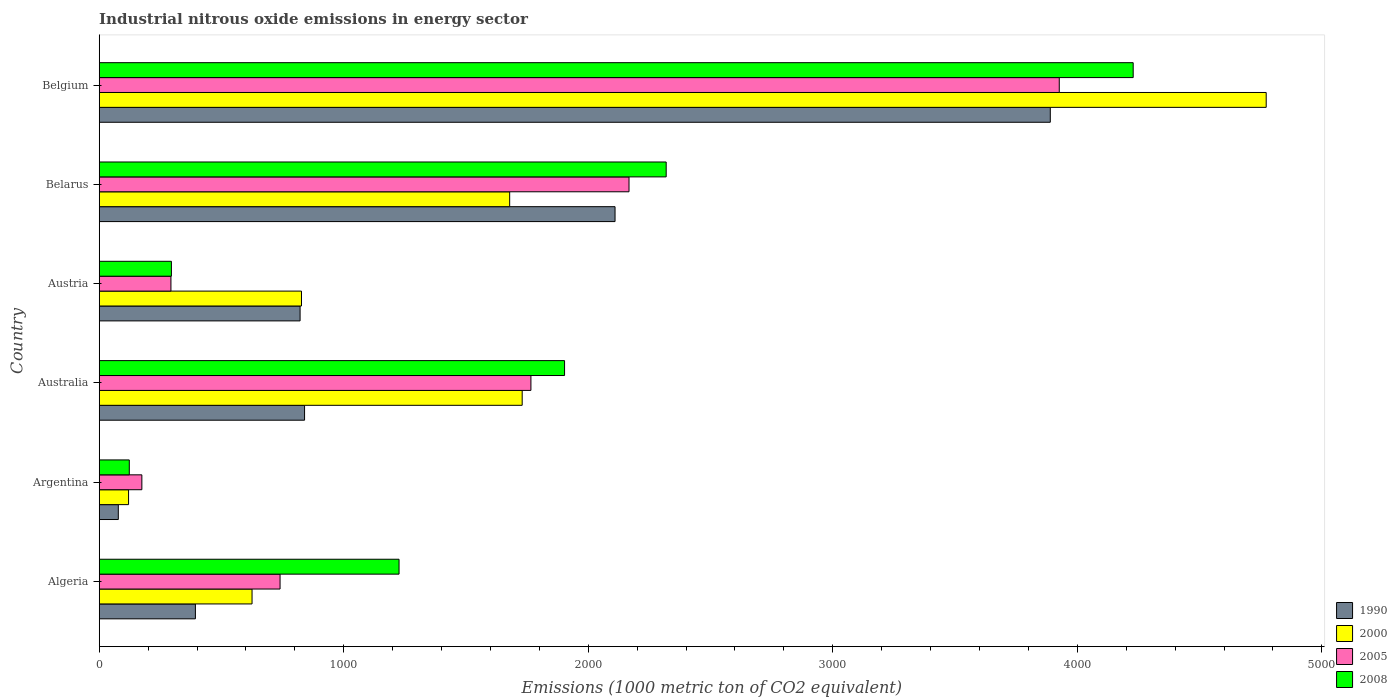How many groups of bars are there?
Make the answer very short. 6. Are the number of bars per tick equal to the number of legend labels?
Give a very brief answer. Yes. What is the label of the 3rd group of bars from the top?
Your response must be concise. Austria. What is the amount of industrial nitrous oxide emitted in 2000 in Algeria?
Provide a short and direct response. 625. Across all countries, what is the maximum amount of industrial nitrous oxide emitted in 1990?
Provide a succinct answer. 3889.6. Across all countries, what is the minimum amount of industrial nitrous oxide emitted in 2000?
Your response must be concise. 120. In which country was the amount of industrial nitrous oxide emitted in 2005 minimum?
Your answer should be very brief. Argentina. What is the total amount of industrial nitrous oxide emitted in 2005 in the graph?
Offer a terse response. 9065.8. What is the difference between the amount of industrial nitrous oxide emitted in 2000 in Algeria and that in Austria?
Provide a short and direct response. -202.2. What is the difference between the amount of industrial nitrous oxide emitted in 2005 in Australia and the amount of industrial nitrous oxide emitted in 2000 in Algeria?
Provide a short and direct response. 1140.5. What is the average amount of industrial nitrous oxide emitted in 2005 per country?
Provide a succinct answer. 1510.97. What is the difference between the amount of industrial nitrous oxide emitted in 2008 and amount of industrial nitrous oxide emitted in 2005 in Argentina?
Your answer should be very brief. -51.4. What is the ratio of the amount of industrial nitrous oxide emitted in 2000 in Austria to that in Belgium?
Keep it short and to the point. 0.17. Is the difference between the amount of industrial nitrous oxide emitted in 2008 in Algeria and Argentina greater than the difference between the amount of industrial nitrous oxide emitted in 2005 in Algeria and Argentina?
Offer a terse response. Yes. What is the difference between the highest and the second highest amount of industrial nitrous oxide emitted in 2000?
Your response must be concise. 3042.8. What is the difference between the highest and the lowest amount of industrial nitrous oxide emitted in 2008?
Ensure brevity in your answer.  4105.6. In how many countries, is the amount of industrial nitrous oxide emitted in 2000 greater than the average amount of industrial nitrous oxide emitted in 2000 taken over all countries?
Provide a short and direct response. 3. Is it the case that in every country, the sum of the amount of industrial nitrous oxide emitted in 2000 and amount of industrial nitrous oxide emitted in 1990 is greater than the sum of amount of industrial nitrous oxide emitted in 2005 and amount of industrial nitrous oxide emitted in 2008?
Give a very brief answer. No. What does the 3rd bar from the top in Belgium represents?
Offer a terse response. 2000. Is it the case that in every country, the sum of the amount of industrial nitrous oxide emitted in 2008 and amount of industrial nitrous oxide emitted in 2005 is greater than the amount of industrial nitrous oxide emitted in 2000?
Give a very brief answer. No. Are all the bars in the graph horizontal?
Offer a terse response. Yes. What is the difference between two consecutive major ticks on the X-axis?
Make the answer very short. 1000. Are the values on the major ticks of X-axis written in scientific E-notation?
Give a very brief answer. No. Does the graph contain any zero values?
Your answer should be very brief. No. Does the graph contain grids?
Make the answer very short. No. How are the legend labels stacked?
Give a very brief answer. Vertical. What is the title of the graph?
Offer a very short reply. Industrial nitrous oxide emissions in energy sector. What is the label or title of the X-axis?
Provide a succinct answer. Emissions (1000 metric ton of CO2 equivalent). What is the Emissions (1000 metric ton of CO2 equivalent) in 1990 in Algeria?
Offer a very short reply. 393.4. What is the Emissions (1000 metric ton of CO2 equivalent) of 2000 in Algeria?
Provide a succinct answer. 625. What is the Emissions (1000 metric ton of CO2 equivalent) of 2005 in Algeria?
Provide a succinct answer. 739.6. What is the Emissions (1000 metric ton of CO2 equivalent) of 2008 in Algeria?
Make the answer very short. 1226.2. What is the Emissions (1000 metric ton of CO2 equivalent) in 1990 in Argentina?
Offer a terse response. 78.1. What is the Emissions (1000 metric ton of CO2 equivalent) of 2000 in Argentina?
Keep it short and to the point. 120. What is the Emissions (1000 metric ton of CO2 equivalent) in 2005 in Argentina?
Provide a succinct answer. 174.4. What is the Emissions (1000 metric ton of CO2 equivalent) in 2008 in Argentina?
Your answer should be compact. 123. What is the Emissions (1000 metric ton of CO2 equivalent) of 1990 in Australia?
Your answer should be very brief. 839.8. What is the Emissions (1000 metric ton of CO2 equivalent) of 2000 in Australia?
Make the answer very short. 1729.8. What is the Emissions (1000 metric ton of CO2 equivalent) in 2005 in Australia?
Provide a short and direct response. 1765.5. What is the Emissions (1000 metric ton of CO2 equivalent) in 2008 in Australia?
Keep it short and to the point. 1903.1. What is the Emissions (1000 metric ton of CO2 equivalent) in 1990 in Austria?
Your answer should be compact. 821.5. What is the Emissions (1000 metric ton of CO2 equivalent) of 2000 in Austria?
Keep it short and to the point. 827.2. What is the Emissions (1000 metric ton of CO2 equivalent) in 2005 in Austria?
Your response must be concise. 293.3. What is the Emissions (1000 metric ton of CO2 equivalent) in 2008 in Austria?
Give a very brief answer. 295.2. What is the Emissions (1000 metric ton of CO2 equivalent) of 1990 in Belarus?
Make the answer very short. 2109.6. What is the Emissions (1000 metric ton of CO2 equivalent) in 2000 in Belarus?
Keep it short and to the point. 1678.6. What is the Emissions (1000 metric ton of CO2 equivalent) of 2005 in Belarus?
Provide a succinct answer. 2166.7. What is the Emissions (1000 metric ton of CO2 equivalent) in 2008 in Belarus?
Give a very brief answer. 2318.7. What is the Emissions (1000 metric ton of CO2 equivalent) in 1990 in Belgium?
Ensure brevity in your answer.  3889.6. What is the Emissions (1000 metric ton of CO2 equivalent) in 2000 in Belgium?
Your response must be concise. 4772.6. What is the Emissions (1000 metric ton of CO2 equivalent) of 2005 in Belgium?
Your response must be concise. 3926.3. What is the Emissions (1000 metric ton of CO2 equivalent) in 2008 in Belgium?
Give a very brief answer. 4228.6. Across all countries, what is the maximum Emissions (1000 metric ton of CO2 equivalent) in 1990?
Offer a terse response. 3889.6. Across all countries, what is the maximum Emissions (1000 metric ton of CO2 equivalent) of 2000?
Ensure brevity in your answer.  4772.6. Across all countries, what is the maximum Emissions (1000 metric ton of CO2 equivalent) of 2005?
Offer a terse response. 3926.3. Across all countries, what is the maximum Emissions (1000 metric ton of CO2 equivalent) in 2008?
Provide a succinct answer. 4228.6. Across all countries, what is the minimum Emissions (1000 metric ton of CO2 equivalent) in 1990?
Ensure brevity in your answer.  78.1. Across all countries, what is the minimum Emissions (1000 metric ton of CO2 equivalent) in 2000?
Provide a short and direct response. 120. Across all countries, what is the minimum Emissions (1000 metric ton of CO2 equivalent) of 2005?
Offer a very short reply. 174.4. Across all countries, what is the minimum Emissions (1000 metric ton of CO2 equivalent) of 2008?
Keep it short and to the point. 123. What is the total Emissions (1000 metric ton of CO2 equivalent) in 1990 in the graph?
Keep it short and to the point. 8132. What is the total Emissions (1000 metric ton of CO2 equivalent) of 2000 in the graph?
Give a very brief answer. 9753.2. What is the total Emissions (1000 metric ton of CO2 equivalent) of 2005 in the graph?
Your answer should be compact. 9065.8. What is the total Emissions (1000 metric ton of CO2 equivalent) in 2008 in the graph?
Offer a very short reply. 1.01e+04. What is the difference between the Emissions (1000 metric ton of CO2 equivalent) of 1990 in Algeria and that in Argentina?
Your answer should be very brief. 315.3. What is the difference between the Emissions (1000 metric ton of CO2 equivalent) of 2000 in Algeria and that in Argentina?
Give a very brief answer. 505. What is the difference between the Emissions (1000 metric ton of CO2 equivalent) in 2005 in Algeria and that in Argentina?
Give a very brief answer. 565.2. What is the difference between the Emissions (1000 metric ton of CO2 equivalent) of 2008 in Algeria and that in Argentina?
Your answer should be compact. 1103.2. What is the difference between the Emissions (1000 metric ton of CO2 equivalent) in 1990 in Algeria and that in Australia?
Keep it short and to the point. -446.4. What is the difference between the Emissions (1000 metric ton of CO2 equivalent) of 2000 in Algeria and that in Australia?
Provide a short and direct response. -1104.8. What is the difference between the Emissions (1000 metric ton of CO2 equivalent) in 2005 in Algeria and that in Australia?
Provide a short and direct response. -1025.9. What is the difference between the Emissions (1000 metric ton of CO2 equivalent) in 2008 in Algeria and that in Australia?
Provide a short and direct response. -676.9. What is the difference between the Emissions (1000 metric ton of CO2 equivalent) of 1990 in Algeria and that in Austria?
Make the answer very short. -428.1. What is the difference between the Emissions (1000 metric ton of CO2 equivalent) in 2000 in Algeria and that in Austria?
Offer a very short reply. -202.2. What is the difference between the Emissions (1000 metric ton of CO2 equivalent) in 2005 in Algeria and that in Austria?
Offer a terse response. 446.3. What is the difference between the Emissions (1000 metric ton of CO2 equivalent) in 2008 in Algeria and that in Austria?
Give a very brief answer. 931. What is the difference between the Emissions (1000 metric ton of CO2 equivalent) in 1990 in Algeria and that in Belarus?
Provide a succinct answer. -1716.2. What is the difference between the Emissions (1000 metric ton of CO2 equivalent) of 2000 in Algeria and that in Belarus?
Ensure brevity in your answer.  -1053.6. What is the difference between the Emissions (1000 metric ton of CO2 equivalent) in 2005 in Algeria and that in Belarus?
Your response must be concise. -1427.1. What is the difference between the Emissions (1000 metric ton of CO2 equivalent) in 2008 in Algeria and that in Belarus?
Provide a short and direct response. -1092.5. What is the difference between the Emissions (1000 metric ton of CO2 equivalent) of 1990 in Algeria and that in Belgium?
Your answer should be compact. -3496.2. What is the difference between the Emissions (1000 metric ton of CO2 equivalent) of 2000 in Algeria and that in Belgium?
Give a very brief answer. -4147.6. What is the difference between the Emissions (1000 metric ton of CO2 equivalent) in 2005 in Algeria and that in Belgium?
Provide a short and direct response. -3186.7. What is the difference between the Emissions (1000 metric ton of CO2 equivalent) in 2008 in Algeria and that in Belgium?
Your answer should be compact. -3002.4. What is the difference between the Emissions (1000 metric ton of CO2 equivalent) in 1990 in Argentina and that in Australia?
Ensure brevity in your answer.  -761.7. What is the difference between the Emissions (1000 metric ton of CO2 equivalent) of 2000 in Argentina and that in Australia?
Your answer should be very brief. -1609.8. What is the difference between the Emissions (1000 metric ton of CO2 equivalent) in 2005 in Argentina and that in Australia?
Provide a succinct answer. -1591.1. What is the difference between the Emissions (1000 metric ton of CO2 equivalent) in 2008 in Argentina and that in Australia?
Offer a terse response. -1780.1. What is the difference between the Emissions (1000 metric ton of CO2 equivalent) of 1990 in Argentina and that in Austria?
Give a very brief answer. -743.4. What is the difference between the Emissions (1000 metric ton of CO2 equivalent) in 2000 in Argentina and that in Austria?
Offer a very short reply. -707.2. What is the difference between the Emissions (1000 metric ton of CO2 equivalent) of 2005 in Argentina and that in Austria?
Provide a short and direct response. -118.9. What is the difference between the Emissions (1000 metric ton of CO2 equivalent) of 2008 in Argentina and that in Austria?
Your response must be concise. -172.2. What is the difference between the Emissions (1000 metric ton of CO2 equivalent) of 1990 in Argentina and that in Belarus?
Ensure brevity in your answer.  -2031.5. What is the difference between the Emissions (1000 metric ton of CO2 equivalent) of 2000 in Argentina and that in Belarus?
Your answer should be compact. -1558.6. What is the difference between the Emissions (1000 metric ton of CO2 equivalent) in 2005 in Argentina and that in Belarus?
Provide a succinct answer. -1992.3. What is the difference between the Emissions (1000 metric ton of CO2 equivalent) of 2008 in Argentina and that in Belarus?
Offer a very short reply. -2195.7. What is the difference between the Emissions (1000 metric ton of CO2 equivalent) in 1990 in Argentina and that in Belgium?
Give a very brief answer. -3811.5. What is the difference between the Emissions (1000 metric ton of CO2 equivalent) in 2000 in Argentina and that in Belgium?
Ensure brevity in your answer.  -4652.6. What is the difference between the Emissions (1000 metric ton of CO2 equivalent) in 2005 in Argentina and that in Belgium?
Ensure brevity in your answer.  -3751.9. What is the difference between the Emissions (1000 metric ton of CO2 equivalent) in 2008 in Argentina and that in Belgium?
Offer a very short reply. -4105.6. What is the difference between the Emissions (1000 metric ton of CO2 equivalent) in 2000 in Australia and that in Austria?
Provide a short and direct response. 902.6. What is the difference between the Emissions (1000 metric ton of CO2 equivalent) of 2005 in Australia and that in Austria?
Give a very brief answer. 1472.2. What is the difference between the Emissions (1000 metric ton of CO2 equivalent) in 2008 in Australia and that in Austria?
Your answer should be very brief. 1607.9. What is the difference between the Emissions (1000 metric ton of CO2 equivalent) of 1990 in Australia and that in Belarus?
Keep it short and to the point. -1269.8. What is the difference between the Emissions (1000 metric ton of CO2 equivalent) of 2000 in Australia and that in Belarus?
Your response must be concise. 51.2. What is the difference between the Emissions (1000 metric ton of CO2 equivalent) in 2005 in Australia and that in Belarus?
Offer a terse response. -401.2. What is the difference between the Emissions (1000 metric ton of CO2 equivalent) in 2008 in Australia and that in Belarus?
Offer a very short reply. -415.6. What is the difference between the Emissions (1000 metric ton of CO2 equivalent) of 1990 in Australia and that in Belgium?
Provide a succinct answer. -3049.8. What is the difference between the Emissions (1000 metric ton of CO2 equivalent) in 2000 in Australia and that in Belgium?
Offer a very short reply. -3042.8. What is the difference between the Emissions (1000 metric ton of CO2 equivalent) in 2005 in Australia and that in Belgium?
Your response must be concise. -2160.8. What is the difference between the Emissions (1000 metric ton of CO2 equivalent) in 2008 in Australia and that in Belgium?
Give a very brief answer. -2325.5. What is the difference between the Emissions (1000 metric ton of CO2 equivalent) in 1990 in Austria and that in Belarus?
Ensure brevity in your answer.  -1288.1. What is the difference between the Emissions (1000 metric ton of CO2 equivalent) in 2000 in Austria and that in Belarus?
Ensure brevity in your answer.  -851.4. What is the difference between the Emissions (1000 metric ton of CO2 equivalent) in 2005 in Austria and that in Belarus?
Your answer should be very brief. -1873.4. What is the difference between the Emissions (1000 metric ton of CO2 equivalent) of 2008 in Austria and that in Belarus?
Give a very brief answer. -2023.5. What is the difference between the Emissions (1000 metric ton of CO2 equivalent) in 1990 in Austria and that in Belgium?
Provide a short and direct response. -3068.1. What is the difference between the Emissions (1000 metric ton of CO2 equivalent) of 2000 in Austria and that in Belgium?
Keep it short and to the point. -3945.4. What is the difference between the Emissions (1000 metric ton of CO2 equivalent) in 2005 in Austria and that in Belgium?
Offer a terse response. -3633. What is the difference between the Emissions (1000 metric ton of CO2 equivalent) in 2008 in Austria and that in Belgium?
Offer a very short reply. -3933.4. What is the difference between the Emissions (1000 metric ton of CO2 equivalent) in 1990 in Belarus and that in Belgium?
Your answer should be very brief. -1780. What is the difference between the Emissions (1000 metric ton of CO2 equivalent) of 2000 in Belarus and that in Belgium?
Keep it short and to the point. -3094. What is the difference between the Emissions (1000 metric ton of CO2 equivalent) in 2005 in Belarus and that in Belgium?
Ensure brevity in your answer.  -1759.6. What is the difference between the Emissions (1000 metric ton of CO2 equivalent) of 2008 in Belarus and that in Belgium?
Make the answer very short. -1909.9. What is the difference between the Emissions (1000 metric ton of CO2 equivalent) in 1990 in Algeria and the Emissions (1000 metric ton of CO2 equivalent) in 2000 in Argentina?
Offer a very short reply. 273.4. What is the difference between the Emissions (1000 metric ton of CO2 equivalent) in 1990 in Algeria and the Emissions (1000 metric ton of CO2 equivalent) in 2005 in Argentina?
Offer a terse response. 219. What is the difference between the Emissions (1000 metric ton of CO2 equivalent) of 1990 in Algeria and the Emissions (1000 metric ton of CO2 equivalent) of 2008 in Argentina?
Provide a succinct answer. 270.4. What is the difference between the Emissions (1000 metric ton of CO2 equivalent) of 2000 in Algeria and the Emissions (1000 metric ton of CO2 equivalent) of 2005 in Argentina?
Provide a short and direct response. 450.6. What is the difference between the Emissions (1000 metric ton of CO2 equivalent) in 2000 in Algeria and the Emissions (1000 metric ton of CO2 equivalent) in 2008 in Argentina?
Keep it short and to the point. 502. What is the difference between the Emissions (1000 metric ton of CO2 equivalent) in 2005 in Algeria and the Emissions (1000 metric ton of CO2 equivalent) in 2008 in Argentina?
Keep it short and to the point. 616.6. What is the difference between the Emissions (1000 metric ton of CO2 equivalent) of 1990 in Algeria and the Emissions (1000 metric ton of CO2 equivalent) of 2000 in Australia?
Keep it short and to the point. -1336.4. What is the difference between the Emissions (1000 metric ton of CO2 equivalent) in 1990 in Algeria and the Emissions (1000 metric ton of CO2 equivalent) in 2005 in Australia?
Your answer should be very brief. -1372.1. What is the difference between the Emissions (1000 metric ton of CO2 equivalent) of 1990 in Algeria and the Emissions (1000 metric ton of CO2 equivalent) of 2008 in Australia?
Your answer should be compact. -1509.7. What is the difference between the Emissions (1000 metric ton of CO2 equivalent) in 2000 in Algeria and the Emissions (1000 metric ton of CO2 equivalent) in 2005 in Australia?
Provide a short and direct response. -1140.5. What is the difference between the Emissions (1000 metric ton of CO2 equivalent) in 2000 in Algeria and the Emissions (1000 metric ton of CO2 equivalent) in 2008 in Australia?
Your response must be concise. -1278.1. What is the difference between the Emissions (1000 metric ton of CO2 equivalent) of 2005 in Algeria and the Emissions (1000 metric ton of CO2 equivalent) of 2008 in Australia?
Ensure brevity in your answer.  -1163.5. What is the difference between the Emissions (1000 metric ton of CO2 equivalent) in 1990 in Algeria and the Emissions (1000 metric ton of CO2 equivalent) in 2000 in Austria?
Provide a short and direct response. -433.8. What is the difference between the Emissions (1000 metric ton of CO2 equivalent) in 1990 in Algeria and the Emissions (1000 metric ton of CO2 equivalent) in 2005 in Austria?
Provide a succinct answer. 100.1. What is the difference between the Emissions (1000 metric ton of CO2 equivalent) in 1990 in Algeria and the Emissions (1000 metric ton of CO2 equivalent) in 2008 in Austria?
Your answer should be compact. 98.2. What is the difference between the Emissions (1000 metric ton of CO2 equivalent) in 2000 in Algeria and the Emissions (1000 metric ton of CO2 equivalent) in 2005 in Austria?
Make the answer very short. 331.7. What is the difference between the Emissions (1000 metric ton of CO2 equivalent) in 2000 in Algeria and the Emissions (1000 metric ton of CO2 equivalent) in 2008 in Austria?
Offer a very short reply. 329.8. What is the difference between the Emissions (1000 metric ton of CO2 equivalent) in 2005 in Algeria and the Emissions (1000 metric ton of CO2 equivalent) in 2008 in Austria?
Your answer should be very brief. 444.4. What is the difference between the Emissions (1000 metric ton of CO2 equivalent) of 1990 in Algeria and the Emissions (1000 metric ton of CO2 equivalent) of 2000 in Belarus?
Your answer should be compact. -1285.2. What is the difference between the Emissions (1000 metric ton of CO2 equivalent) of 1990 in Algeria and the Emissions (1000 metric ton of CO2 equivalent) of 2005 in Belarus?
Your answer should be very brief. -1773.3. What is the difference between the Emissions (1000 metric ton of CO2 equivalent) in 1990 in Algeria and the Emissions (1000 metric ton of CO2 equivalent) in 2008 in Belarus?
Ensure brevity in your answer.  -1925.3. What is the difference between the Emissions (1000 metric ton of CO2 equivalent) of 2000 in Algeria and the Emissions (1000 metric ton of CO2 equivalent) of 2005 in Belarus?
Offer a terse response. -1541.7. What is the difference between the Emissions (1000 metric ton of CO2 equivalent) in 2000 in Algeria and the Emissions (1000 metric ton of CO2 equivalent) in 2008 in Belarus?
Ensure brevity in your answer.  -1693.7. What is the difference between the Emissions (1000 metric ton of CO2 equivalent) in 2005 in Algeria and the Emissions (1000 metric ton of CO2 equivalent) in 2008 in Belarus?
Your response must be concise. -1579.1. What is the difference between the Emissions (1000 metric ton of CO2 equivalent) in 1990 in Algeria and the Emissions (1000 metric ton of CO2 equivalent) in 2000 in Belgium?
Your answer should be very brief. -4379.2. What is the difference between the Emissions (1000 metric ton of CO2 equivalent) in 1990 in Algeria and the Emissions (1000 metric ton of CO2 equivalent) in 2005 in Belgium?
Offer a very short reply. -3532.9. What is the difference between the Emissions (1000 metric ton of CO2 equivalent) in 1990 in Algeria and the Emissions (1000 metric ton of CO2 equivalent) in 2008 in Belgium?
Your answer should be compact. -3835.2. What is the difference between the Emissions (1000 metric ton of CO2 equivalent) of 2000 in Algeria and the Emissions (1000 metric ton of CO2 equivalent) of 2005 in Belgium?
Provide a short and direct response. -3301.3. What is the difference between the Emissions (1000 metric ton of CO2 equivalent) of 2000 in Algeria and the Emissions (1000 metric ton of CO2 equivalent) of 2008 in Belgium?
Provide a succinct answer. -3603.6. What is the difference between the Emissions (1000 metric ton of CO2 equivalent) in 2005 in Algeria and the Emissions (1000 metric ton of CO2 equivalent) in 2008 in Belgium?
Ensure brevity in your answer.  -3489. What is the difference between the Emissions (1000 metric ton of CO2 equivalent) in 1990 in Argentina and the Emissions (1000 metric ton of CO2 equivalent) in 2000 in Australia?
Your answer should be very brief. -1651.7. What is the difference between the Emissions (1000 metric ton of CO2 equivalent) in 1990 in Argentina and the Emissions (1000 metric ton of CO2 equivalent) in 2005 in Australia?
Your answer should be very brief. -1687.4. What is the difference between the Emissions (1000 metric ton of CO2 equivalent) in 1990 in Argentina and the Emissions (1000 metric ton of CO2 equivalent) in 2008 in Australia?
Your answer should be compact. -1825. What is the difference between the Emissions (1000 metric ton of CO2 equivalent) of 2000 in Argentina and the Emissions (1000 metric ton of CO2 equivalent) of 2005 in Australia?
Keep it short and to the point. -1645.5. What is the difference between the Emissions (1000 metric ton of CO2 equivalent) in 2000 in Argentina and the Emissions (1000 metric ton of CO2 equivalent) in 2008 in Australia?
Provide a short and direct response. -1783.1. What is the difference between the Emissions (1000 metric ton of CO2 equivalent) in 2005 in Argentina and the Emissions (1000 metric ton of CO2 equivalent) in 2008 in Australia?
Provide a short and direct response. -1728.7. What is the difference between the Emissions (1000 metric ton of CO2 equivalent) of 1990 in Argentina and the Emissions (1000 metric ton of CO2 equivalent) of 2000 in Austria?
Offer a very short reply. -749.1. What is the difference between the Emissions (1000 metric ton of CO2 equivalent) in 1990 in Argentina and the Emissions (1000 metric ton of CO2 equivalent) in 2005 in Austria?
Your response must be concise. -215.2. What is the difference between the Emissions (1000 metric ton of CO2 equivalent) of 1990 in Argentina and the Emissions (1000 metric ton of CO2 equivalent) of 2008 in Austria?
Provide a succinct answer. -217.1. What is the difference between the Emissions (1000 metric ton of CO2 equivalent) of 2000 in Argentina and the Emissions (1000 metric ton of CO2 equivalent) of 2005 in Austria?
Provide a short and direct response. -173.3. What is the difference between the Emissions (1000 metric ton of CO2 equivalent) in 2000 in Argentina and the Emissions (1000 metric ton of CO2 equivalent) in 2008 in Austria?
Provide a succinct answer. -175.2. What is the difference between the Emissions (1000 metric ton of CO2 equivalent) in 2005 in Argentina and the Emissions (1000 metric ton of CO2 equivalent) in 2008 in Austria?
Provide a short and direct response. -120.8. What is the difference between the Emissions (1000 metric ton of CO2 equivalent) in 1990 in Argentina and the Emissions (1000 metric ton of CO2 equivalent) in 2000 in Belarus?
Your answer should be very brief. -1600.5. What is the difference between the Emissions (1000 metric ton of CO2 equivalent) of 1990 in Argentina and the Emissions (1000 metric ton of CO2 equivalent) of 2005 in Belarus?
Provide a succinct answer. -2088.6. What is the difference between the Emissions (1000 metric ton of CO2 equivalent) in 1990 in Argentina and the Emissions (1000 metric ton of CO2 equivalent) in 2008 in Belarus?
Your answer should be compact. -2240.6. What is the difference between the Emissions (1000 metric ton of CO2 equivalent) in 2000 in Argentina and the Emissions (1000 metric ton of CO2 equivalent) in 2005 in Belarus?
Offer a very short reply. -2046.7. What is the difference between the Emissions (1000 metric ton of CO2 equivalent) of 2000 in Argentina and the Emissions (1000 metric ton of CO2 equivalent) of 2008 in Belarus?
Ensure brevity in your answer.  -2198.7. What is the difference between the Emissions (1000 metric ton of CO2 equivalent) of 2005 in Argentina and the Emissions (1000 metric ton of CO2 equivalent) of 2008 in Belarus?
Give a very brief answer. -2144.3. What is the difference between the Emissions (1000 metric ton of CO2 equivalent) of 1990 in Argentina and the Emissions (1000 metric ton of CO2 equivalent) of 2000 in Belgium?
Provide a succinct answer. -4694.5. What is the difference between the Emissions (1000 metric ton of CO2 equivalent) of 1990 in Argentina and the Emissions (1000 metric ton of CO2 equivalent) of 2005 in Belgium?
Provide a succinct answer. -3848.2. What is the difference between the Emissions (1000 metric ton of CO2 equivalent) in 1990 in Argentina and the Emissions (1000 metric ton of CO2 equivalent) in 2008 in Belgium?
Provide a succinct answer. -4150.5. What is the difference between the Emissions (1000 metric ton of CO2 equivalent) in 2000 in Argentina and the Emissions (1000 metric ton of CO2 equivalent) in 2005 in Belgium?
Your answer should be very brief. -3806.3. What is the difference between the Emissions (1000 metric ton of CO2 equivalent) of 2000 in Argentina and the Emissions (1000 metric ton of CO2 equivalent) of 2008 in Belgium?
Provide a succinct answer. -4108.6. What is the difference between the Emissions (1000 metric ton of CO2 equivalent) in 2005 in Argentina and the Emissions (1000 metric ton of CO2 equivalent) in 2008 in Belgium?
Make the answer very short. -4054.2. What is the difference between the Emissions (1000 metric ton of CO2 equivalent) in 1990 in Australia and the Emissions (1000 metric ton of CO2 equivalent) in 2005 in Austria?
Offer a terse response. 546.5. What is the difference between the Emissions (1000 metric ton of CO2 equivalent) of 1990 in Australia and the Emissions (1000 metric ton of CO2 equivalent) of 2008 in Austria?
Make the answer very short. 544.6. What is the difference between the Emissions (1000 metric ton of CO2 equivalent) in 2000 in Australia and the Emissions (1000 metric ton of CO2 equivalent) in 2005 in Austria?
Your answer should be very brief. 1436.5. What is the difference between the Emissions (1000 metric ton of CO2 equivalent) in 2000 in Australia and the Emissions (1000 metric ton of CO2 equivalent) in 2008 in Austria?
Offer a terse response. 1434.6. What is the difference between the Emissions (1000 metric ton of CO2 equivalent) in 2005 in Australia and the Emissions (1000 metric ton of CO2 equivalent) in 2008 in Austria?
Provide a succinct answer. 1470.3. What is the difference between the Emissions (1000 metric ton of CO2 equivalent) of 1990 in Australia and the Emissions (1000 metric ton of CO2 equivalent) of 2000 in Belarus?
Offer a very short reply. -838.8. What is the difference between the Emissions (1000 metric ton of CO2 equivalent) in 1990 in Australia and the Emissions (1000 metric ton of CO2 equivalent) in 2005 in Belarus?
Keep it short and to the point. -1326.9. What is the difference between the Emissions (1000 metric ton of CO2 equivalent) of 1990 in Australia and the Emissions (1000 metric ton of CO2 equivalent) of 2008 in Belarus?
Offer a terse response. -1478.9. What is the difference between the Emissions (1000 metric ton of CO2 equivalent) of 2000 in Australia and the Emissions (1000 metric ton of CO2 equivalent) of 2005 in Belarus?
Make the answer very short. -436.9. What is the difference between the Emissions (1000 metric ton of CO2 equivalent) in 2000 in Australia and the Emissions (1000 metric ton of CO2 equivalent) in 2008 in Belarus?
Make the answer very short. -588.9. What is the difference between the Emissions (1000 metric ton of CO2 equivalent) of 2005 in Australia and the Emissions (1000 metric ton of CO2 equivalent) of 2008 in Belarus?
Your response must be concise. -553.2. What is the difference between the Emissions (1000 metric ton of CO2 equivalent) in 1990 in Australia and the Emissions (1000 metric ton of CO2 equivalent) in 2000 in Belgium?
Provide a short and direct response. -3932.8. What is the difference between the Emissions (1000 metric ton of CO2 equivalent) in 1990 in Australia and the Emissions (1000 metric ton of CO2 equivalent) in 2005 in Belgium?
Give a very brief answer. -3086.5. What is the difference between the Emissions (1000 metric ton of CO2 equivalent) in 1990 in Australia and the Emissions (1000 metric ton of CO2 equivalent) in 2008 in Belgium?
Your answer should be compact. -3388.8. What is the difference between the Emissions (1000 metric ton of CO2 equivalent) in 2000 in Australia and the Emissions (1000 metric ton of CO2 equivalent) in 2005 in Belgium?
Offer a very short reply. -2196.5. What is the difference between the Emissions (1000 metric ton of CO2 equivalent) of 2000 in Australia and the Emissions (1000 metric ton of CO2 equivalent) of 2008 in Belgium?
Provide a short and direct response. -2498.8. What is the difference between the Emissions (1000 metric ton of CO2 equivalent) in 2005 in Australia and the Emissions (1000 metric ton of CO2 equivalent) in 2008 in Belgium?
Your answer should be very brief. -2463.1. What is the difference between the Emissions (1000 metric ton of CO2 equivalent) of 1990 in Austria and the Emissions (1000 metric ton of CO2 equivalent) of 2000 in Belarus?
Provide a short and direct response. -857.1. What is the difference between the Emissions (1000 metric ton of CO2 equivalent) in 1990 in Austria and the Emissions (1000 metric ton of CO2 equivalent) in 2005 in Belarus?
Your response must be concise. -1345.2. What is the difference between the Emissions (1000 metric ton of CO2 equivalent) in 1990 in Austria and the Emissions (1000 metric ton of CO2 equivalent) in 2008 in Belarus?
Give a very brief answer. -1497.2. What is the difference between the Emissions (1000 metric ton of CO2 equivalent) in 2000 in Austria and the Emissions (1000 metric ton of CO2 equivalent) in 2005 in Belarus?
Your response must be concise. -1339.5. What is the difference between the Emissions (1000 metric ton of CO2 equivalent) in 2000 in Austria and the Emissions (1000 metric ton of CO2 equivalent) in 2008 in Belarus?
Give a very brief answer. -1491.5. What is the difference between the Emissions (1000 metric ton of CO2 equivalent) of 2005 in Austria and the Emissions (1000 metric ton of CO2 equivalent) of 2008 in Belarus?
Give a very brief answer. -2025.4. What is the difference between the Emissions (1000 metric ton of CO2 equivalent) in 1990 in Austria and the Emissions (1000 metric ton of CO2 equivalent) in 2000 in Belgium?
Give a very brief answer. -3951.1. What is the difference between the Emissions (1000 metric ton of CO2 equivalent) in 1990 in Austria and the Emissions (1000 metric ton of CO2 equivalent) in 2005 in Belgium?
Provide a succinct answer. -3104.8. What is the difference between the Emissions (1000 metric ton of CO2 equivalent) of 1990 in Austria and the Emissions (1000 metric ton of CO2 equivalent) of 2008 in Belgium?
Provide a succinct answer. -3407.1. What is the difference between the Emissions (1000 metric ton of CO2 equivalent) of 2000 in Austria and the Emissions (1000 metric ton of CO2 equivalent) of 2005 in Belgium?
Ensure brevity in your answer.  -3099.1. What is the difference between the Emissions (1000 metric ton of CO2 equivalent) of 2000 in Austria and the Emissions (1000 metric ton of CO2 equivalent) of 2008 in Belgium?
Offer a terse response. -3401.4. What is the difference between the Emissions (1000 metric ton of CO2 equivalent) in 2005 in Austria and the Emissions (1000 metric ton of CO2 equivalent) in 2008 in Belgium?
Make the answer very short. -3935.3. What is the difference between the Emissions (1000 metric ton of CO2 equivalent) in 1990 in Belarus and the Emissions (1000 metric ton of CO2 equivalent) in 2000 in Belgium?
Provide a short and direct response. -2663. What is the difference between the Emissions (1000 metric ton of CO2 equivalent) of 1990 in Belarus and the Emissions (1000 metric ton of CO2 equivalent) of 2005 in Belgium?
Keep it short and to the point. -1816.7. What is the difference between the Emissions (1000 metric ton of CO2 equivalent) in 1990 in Belarus and the Emissions (1000 metric ton of CO2 equivalent) in 2008 in Belgium?
Offer a terse response. -2119. What is the difference between the Emissions (1000 metric ton of CO2 equivalent) in 2000 in Belarus and the Emissions (1000 metric ton of CO2 equivalent) in 2005 in Belgium?
Your response must be concise. -2247.7. What is the difference between the Emissions (1000 metric ton of CO2 equivalent) in 2000 in Belarus and the Emissions (1000 metric ton of CO2 equivalent) in 2008 in Belgium?
Ensure brevity in your answer.  -2550. What is the difference between the Emissions (1000 metric ton of CO2 equivalent) of 2005 in Belarus and the Emissions (1000 metric ton of CO2 equivalent) of 2008 in Belgium?
Give a very brief answer. -2061.9. What is the average Emissions (1000 metric ton of CO2 equivalent) of 1990 per country?
Offer a very short reply. 1355.33. What is the average Emissions (1000 metric ton of CO2 equivalent) in 2000 per country?
Provide a short and direct response. 1625.53. What is the average Emissions (1000 metric ton of CO2 equivalent) in 2005 per country?
Offer a terse response. 1510.97. What is the average Emissions (1000 metric ton of CO2 equivalent) in 2008 per country?
Provide a succinct answer. 1682.47. What is the difference between the Emissions (1000 metric ton of CO2 equivalent) of 1990 and Emissions (1000 metric ton of CO2 equivalent) of 2000 in Algeria?
Give a very brief answer. -231.6. What is the difference between the Emissions (1000 metric ton of CO2 equivalent) in 1990 and Emissions (1000 metric ton of CO2 equivalent) in 2005 in Algeria?
Offer a terse response. -346.2. What is the difference between the Emissions (1000 metric ton of CO2 equivalent) in 1990 and Emissions (1000 metric ton of CO2 equivalent) in 2008 in Algeria?
Make the answer very short. -832.8. What is the difference between the Emissions (1000 metric ton of CO2 equivalent) of 2000 and Emissions (1000 metric ton of CO2 equivalent) of 2005 in Algeria?
Ensure brevity in your answer.  -114.6. What is the difference between the Emissions (1000 metric ton of CO2 equivalent) of 2000 and Emissions (1000 metric ton of CO2 equivalent) of 2008 in Algeria?
Give a very brief answer. -601.2. What is the difference between the Emissions (1000 metric ton of CO2 equivalent) in 2005 and Emissions (1000 metric ton of CO2 equivalent) in 2008 in Algeria?
Provide a short and direct response. -486.6. What is the difference between the Emissions (1000 metric ton of CO2 equivalent) of 1990 and Emissions (1000 metric ton of CO2 equivalent) of 2000 in Argentina?
Give a very brief answer. -41.9. What is the difference between the Emissions (1000 metric ton of CO2 equivalent) of 1990 and Emissions (1000 metric ton of CO2 equivalent) of 2005 in Argentina?
Provide a succinct answer. -96.3. What is the difference between the Emissions (1000 metric ton of CO2 equivalent) in 1990 and Emissions (1000 metric ton of CO2 equivalent) in 2008 in Argentina?
Your answer should be very brief. -44.9. What is the difference between the Emissions (1000 metric ton of CO2 equivalent) of 2000 and Emissions (1000 metric ton of CO2 equivalent) of 2005 in Argentina?
Offer a terse response. -54.4. What is the difference between the Emissions (1000 metric ton of CO2 equivalent) of 2005 and Emissions (1000 metric ton of CO2 equivalent) of 2008 in Argentina?
Your response must be concise. 51.4. What is the difference between the Emissions (1000 metric ton of CO2 equivalent) in 1990 and Emissions (1000 metric ton of CO2 equivalent) in 2000 in Australia?
Provide a succinct answer. -890. What is the difference between the Emissions (1000 metric ton of CO2 equivalent) in 1990 and Emissions (1000 metric ton of CO2 equivalent) in 2005 in Australia?
Offer a very short reply. -925.7. What is the difference between the Emissions (1000 metric ton of CO2 equivalent) in 1990 and Emissions (1000 metric ton of CO2 equivalent) in 2008 in Australia?
Your answer should be compact. -1063.3. What is the difference between the Emissions (1000 metric ton of CO2 equivalent) of 2000 and Emissions (1000 metric ton of CO2 equivalent) of 2005 in Australia?
Offer a terse response. -35.7. What is the difference between the Emissions (1000 metric ton of CO2 equivalent) of 2000 and Emissions (1000 metric ton of CO2 equivalent) of 2008 in Australia?
Ensure brevity in your answer.  -173.3. What is the difference between the Emissions (1000 metric ton of CO2 equivalent) of 2005 and Emissions (1000 metric ton of CO2 equivalent) of 2008 in Australia?
Your answer should be very brief. -137.6. What is the difference between the Emissions (1000 metric ton of CO2 equivalent) in 1990 and Emissions (1000 metric ton of CO2 equivalent) in 2005 in Austria?
Provide a succinct answer. 528.2. What is the difference between the Emissions (1000 metric ton of CO2 equivalent) in 1990 and Emissions (1000 metric ton of CO2 equivalent) in 2008 in Austria?
Make the answer very short. 526.3. What is the difference between the Emissions (1000 metric ton of CO2 equivalent) of 2000 and Emissions (1000 metric ton of CO2 equivalent) of 2005 in Austria?
Make the answer very short. 533.9. What is the difference between the Emissions (1000 metric ton of CO2 equivalent) of 2000 and Emissions (1000 metric ton of CO2 equivalent) of 2008 in Austria?
Make the answer very short. 532. What is the difference between the Emissions (1000 metric ton of CO2 equivalent) of 2005 and Emissions (1000 metric ton of CO2 equivalent) of 2008 in Austria?
Provide a succinct answer. -1.9. What is the difference between the Emissions (1000 metric ton of CO2 equivalent) in 1990 and Emissions (1000 metric ton of CO2 equivalent) in 2000 in Belarus?
Provide a succinct answer. 431. What is the difference between the Emissions (1000 metric ton of CO2 equivalent) of 1990 and Emissions (1000 metric ton of CO2 equivalent) of 2005 in Belarus?
Give a very brief answer. -57.1. What is the difference between the Emissions (1000 metric ton of CO2 equivalent) in 1990 and Emissions (1000 metric ton of CO2 equivalent) in 2008 in Belarus?
Make the answer very short. -209.1. What is the difference between the Emissions (1000 metric ton of CO2 equivalent) of 2000 and Emissions (1000 metric ton of CO2 equivalent) of 2005 in Belarus?
Make the answer very short. -488.1. What is the difference between the Emissions (1000 metric ton of CO2 equivalent) of 2000 and Emissions (1000 metric ton of CO2 equivalent) of 2008 in Belarus?
Provide a short and direct response. -640.1. What is the difference between the Emissions (1000 metric ton of CO2 equivalent) in 2005 and Emissions (1000 metric ton of CO2 equivalent) in 2008 in Belarus?
Offer a very short reply. -152. What is the difference between the Emissions (1000 metric ton of CO2 equivalent) in 1990 and Emissions (1000 metric ton of CO2 equivalent) in 2000 in Belgium?
Keep it short and to the point. -883. What is the difference between the Emissions (1000 metric ton of CO2 equivalent) of 1990 and Emissions (1000 metric ton of CO2 equivalent) of 2005 in Belgium?
Your answer should be very brief. -36.7. What is the difference between the Emissions (1000 metric ton of CO2 equivalent) of 1990 and Emissions (1000 metric ton of CO2 equivalent) of 2008 in Belgium?
Your response must be concise. -339. What is the difference between the Emissions (1000 metric ton of CO2 equivalent) of 2000 and Emissions (1000 metric ton of CO2 equivalent) of 2005 in Belgium?
Ensure brevity in your answer.  846.3. What is the difference between the Emissions (1000 metric ton of CO2 equivalent) of 2000 and Emissions (1000 metric ton of CO2 equivalent) of 2008 in Belgium?
Offer a terse response. 544. What is the difference between the Emissions (1000 metric ton of CO2 equivalent) in 2005 and Emissions (1000 metric ton of CO2 equivalent) in 2008 in Belgium?
Your answer should be compact. -302.3. What is the ratio of the Emissions (1000 metric ton of CO2 equivalent) of 1990 in Algeria to that in Argentina?
Ensure brevity in your answer.  5.04. What is the ratio of the Emissions (1000 metric ton of CO2 equivalent) of 2000 in Algeria to that in Argentina?
Make the answer very short. 5.21. What is the ratio of the Emissions (1000 metric ton of CO2 equivalent) in 2005 in Algeria to that in Argentina?
Give a very brief answer. 4.24. What is the ratio of the Emissions (1000 metric ton of CO2 equivalent) in 2008 in Algeria to that in Argentina?
Provide a short and direct response. 9.97. What is the ratio of the Emissions (1000 metric ton of CO2 equivalent) of 1990 in Algeria to that in Australia?
Give a very brief answer. 0.47. What is the ratio of the Emissions (1000 metric ton of CO2 equivalent) in 2000 in Algeria to that in Australia?
Offer a terse response. 0.36. What is the ratio of the Emissions (1000 metric ton of CO2 equivalent) in 2005 in Algeria to that in Australia?
Your answer should be very brief. 0.42. What is the ratio of the Emissions (1000 metric ton of CO2 equivalent) of 2008 in Algeria to that in Australia?
Provide a succinct answer. 0.64. What is the ratio of the Emissions (1000 metric ton of CO2 equivalent) in 1990 in Algeria to that in Austria?
Offer a terse response. 0.48. What is the ratio of the Emissions (1000 metric ton of CO2 equivalent) of 2000 in Algeria to that in Austria?
Your answer should be very brief. 0.76. What is the ratio of the Emissions (1000 metric ton of CO2 equivalent) in 2005 in Algeria to that in Austria?
Your answer should be compact. 2.52. What is the ratio of the Emissions (1000 metric ton of CO2 equivalent) of 2008 in Algeria to that in Austria?
Offer a very short reply. 4.15. What is the ratio of the Emissions (1000 metric ton of CO2 equivalent) of 1990 in Algeria to that in Belarus?
Keep it short and to the point. 0.19. What is the ratio of the Emissions (1000 metric ton of CO2 equivalent) in 2000 in Algeria to that in Belarus?
Offer a terse response. 0.37. What is the ratio of the Emissions (1000 metric ton of CO2 equivalent) in 2005 in Algeria to that in Belarus?
Offer a terse response. 0.34. What is the ratio of the Emissions (1000 metric ton of CO2 equivalent) of 2008 in Algeria to that in Belarus?
Offer a terse response. 0.53. What is the ratio of the Emissions (1000 metric ton of CO2 equivalent) of 1990 in Algeria to that in Belgium?
Provide a succinct answer. 0.1. What is the ratio of the Emissions (1000 metric ton of CO2 equivalent) of 2000 in Algeria to that in Belgium?
Offer a terse response. 0.13. What is the ratio of the Emissions (1000 metric ton of CO2 equivalent) of 2005 in Algeria to that in Belgium?
Offer a very short reply. 0.19. What is the ratio of the Emissions (1000 metric ton of CO2 equivalent) of 2008 in Algeria to that in Belgium?
Give a very brief answer. 0.29. What is the ratio of the Emissions (1000 metric ton of CO2 equivalent) of 1990 in Argentina to that in Australia?
Keep it short and to the point. 0.09. What is the ratio of the Emissions (1000 metric ton of CO2 equivalent) of 2000 in Argentina to that in Australia?
Your response must be concise. 0.07. What is the ratio of the Emissions (1000 metric ton of CO2 equivalent) of 2005 in Argentina to that in Australia?
Offer a very short reply. 0.1. What is the ratio of the Emissions (1000 metric ton of CO2 equivalent) of 2008 in Argentina to that in Australia?
Offer a terse response. 0.06. What is the ratio of the Emissions (1000 metric ton of CO2 equivalent) of 1990 in Argentina to that in Austria?
Offer a terse response. 0.1. What is the ratio of the Emissions (1000 metric ton of CO2 equivalent) of 2000 in Argentina to that in Austria?
Keep it short and to the point. 0.15. What is the ratio of the Emissions (1000 metric ton of CO2 equivalent) of 2005 in Argentina to that in Austria?
Make the answer very short. 0.59. What is the ratio of the Emissions (1000 metric ton of CO2 equivalent) of 2008 in Argentina to that in Austria?
Offer a terse response. 0.42. What is the ratio of the Emissions (1000 metric ton of CO2 equivalent) of 1990 in Argentina to that in Belarus?
Offer a terse response. 0.04. What is the ratio of the Emissions (1000 metric ton of CO2 equivalent) of 2000 in Argentina to that in Belarus?
Offer a terse response. 0.07. What is the ratio of the Emissions (1000 metric ton of CO2 equivalent) of 2005 in Argentina to that in Belarus?
Offer a terse response. 0.08. What is the ratio of the Emissions (1000 metric ton of CO2 equivalent) of 2008 in Argentina to that in Belarus?
Ensure brevity in your answer.  0.05. What is the ratio of the Emissions (1000 metric ton of CO2 equivalent) of 1990 in Argentina to that in Belgium?
Make the answer very short. 0.02. What is the ratio of the Emissions (1000 metric ton of CO2 equivalent) of 2000 in Argentina to that in Belgium?
Your answer should be compact. 0.03. What is the ratio of the Emissions (1000 metric ton of CO2 equivalent) in 2005 in Argentina to that in Belgium?
Provide a short and direct response. 0.04. What is the ratio of the Emissions (1000 metric ton of CO2 equivalent) of 2008 in Argentina to that in Belgium?
Keep it short and to the point. 0.03. What is the ratio of the Emissions (1000 metric ton of CO2 equivalent) in 1990 in Australia to that in Austria?
Offer a very short reply. 1.02. What is the ratio of the Emissions (1000 metric ton of CO2 equivalent) in 2000 in Australia to that in Austria?
Your response must be concise. 2.09. What is the ratio of the Emissions (1000 metric ton of CO2 equivalent) in 2005 in Australia to that in Austria?
Your answer should be compact. 6.02. What is the ratio of the Emissions (1000 metric ton of CO2 equivalent) of 2008 in Australia to that in Austria?
Offer a very short reply. 6.45. What is the ratio of the Emissions (1000 metric ton of CO2 equivalent) of 1990 in Australia to that in Belarus?
Provide a short and direct response. 0.4. What is the ratio of the Emissions (1000 metric ton of CO2 equivalent) in 2000 in Australia to that in Belarus?
Your response must be concise. 1.03. What is the ratio of the Emissions (1000 metric ton of CO2 equivalent) in 2005 in Australia to that in Belarus?
Offer a terse response. 0.81. What is the ratio of the Emissions (1000 metric ton of CO2 equivalent) in 2008 in Australia to that in Belarus?
Ensure brevity in your answer.  0.82. What is the ratio of the Emissions (1000 metric ton of CO2 equivalent) of 1990 in Australia to that in Belgium?
Give a very brief answer. 0.22. What is the ratio of the Emissions (1000 metric ton of CO2 equivalent) in 2000 in Australia to that in Belgium?
Provide a short and direct response. 0.36. What is the ratio of the Emissions (1000 metric ton of CO2 equivalent) of 2005 in Australia to that in Belgium?
Provide a succinct answer. 0.45. What is the ratio of the Emissions (1000 metric ton of CO2 equivalent) in 2008 in Australia to that in Belgium?
Your answer should be compact. 0.45. What is the ratio of the Emissions (1000 metric ton of CO2 equivalent) of 1990 in Austria to that in Belarus?
Give a very brief answer. 0.39. What is the ratio of the Emissions (1000 metric ton of CO2 equivalent) in 2000 in Austria to that in Belarus?
Offer a terse response. 0.49. What is the ratio of the Emissions (1000 metric ton of CO2 equivalent) in 2005 in Austria to that in Belarus?
Make the answer very short. 0.14. What is the ratio of the Emissions (1000 metric ton of CO2 equivalent) in 2008 in Austria to that in Belarus?
Provide a short and direct response. 0.13. What is the ratio of the Emissions (1000 metric ton of CO2 equivalent) in 1990 in Austria to that in Belgium?
Your answer should be compact. 0.21. What is the ratio of the Emissions (1000 metric ton of CO2 equivalent) in 2000 in Austria to that in Belgium?
Ensure brevity in your answer.  0.17. What is the ratio of the Emissions (1000 metric ton of CO2 equivalent) of 2005 in Austria to that in Belgium?
Offer a terse response. 0.07. What is the ratio of the Emissions (1000 metric ton of CO2 equivalent) in 2008 in Austria to that in Belgium?
Ensure brevity in your answer.  0.07. What is the ratio of the Emissions (1000 metric ton of CO2 equivalent) of 1990 in Belarus to that in Belgium?
Offer a very short reply. 0.54. What is the ratio of the Emissions (1000 metric ton of CO2 equivalent) of 2000 in Belarus to that in Belgium?
Offer a terse response. 0.35. What is the ratio of the Emissions (1000 metric ton of CO2 equivalent) in 2005 in Belarus to that in Belgium?
Provide a succinct answer. 0.55. What is the ratio of the Emissions (1000 metric ton of CO2 equivalent) in 2008 in Belarus to that in Belgium?
Your response must be concise. 0.55. What is the difference between the highest and the second highest Emissions (1000 metric ton of CO2 equivalent) in 1990?
Ensure brevity in your answer.  1780. What is the difference between the highest and the second highest Emissions (1000 metric ton of CO2 equivalent) in 2000?
Your response must be concise. 3042.8. What is the difference between the highest and the second highest Emissions (1000 metric ton of CO2 equivalent) in 2005?
Your response must be concise. 1759.6. What is the difference between the highest and the second highest Emissions (1000 metric ton of CO2 equivalent) in 2008?
Keep it short and to the point. 1909.9. What is the difference between the highest and the lowest Emissions (1000 metric ton of CO2 equivalent) of 1990?
Give a very brief answer. 3811.5. What is the difference between the highest and the lowest Emissions (1000 metric ton of CO2 equivalent) of 2000?
Your response must be concise. 4652.6. What is the difference between the highest and the lowest Emissions (1000 metric ton of CO2 equivalent) in 2005?
Keep it short and to the point. 3751.9. What is the difference between the highest and the lowest Emissions (1000 metric ton of CO2 equivalent) of 2008?
Offer a terse response. 4105.6. 